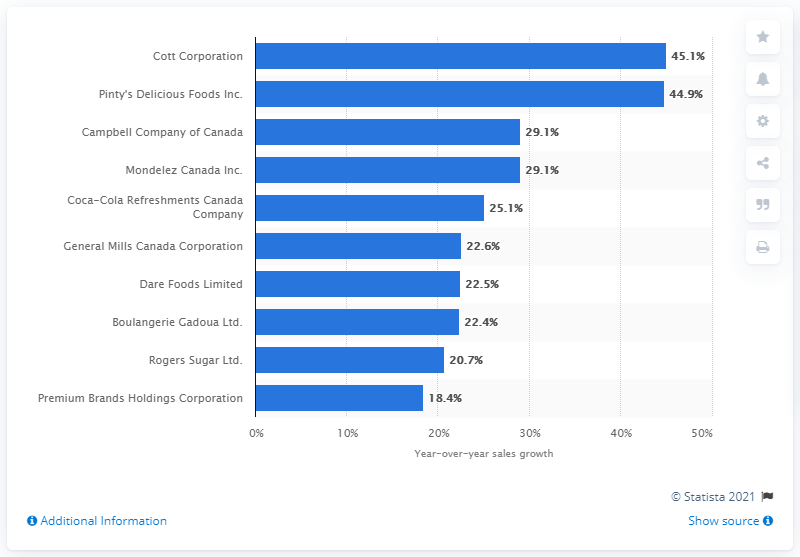Specify some key components in this picture. In 2017, the sales growth of Cott Corporation was 45.1%. In 2017, Cott Corporation was recognized as the fastest growing food and beverage company in Canada. 